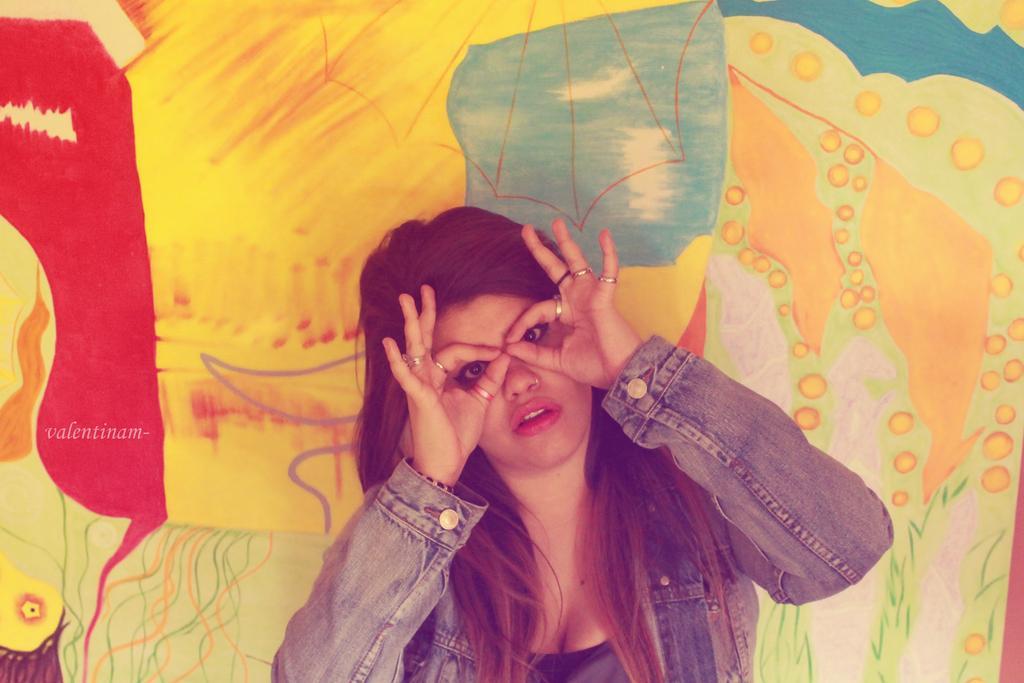Could you give a brief overview of what you see in this image? In this picture we can see a woman. In the background there is a painting. 